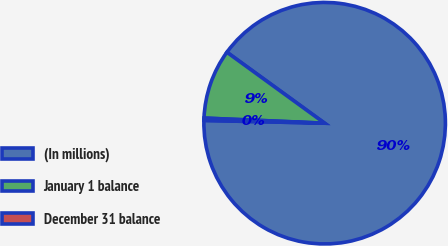Convert chart. <chart><loc_0><loc_0><loc_500><loc_500><pie_chart><fcel>(In millions)<fcel>January 1 balance<fcel>December 31 balance<nl><fcel>90.37%<fcel>9.32%<fcel>0.31%<nl></chart> 